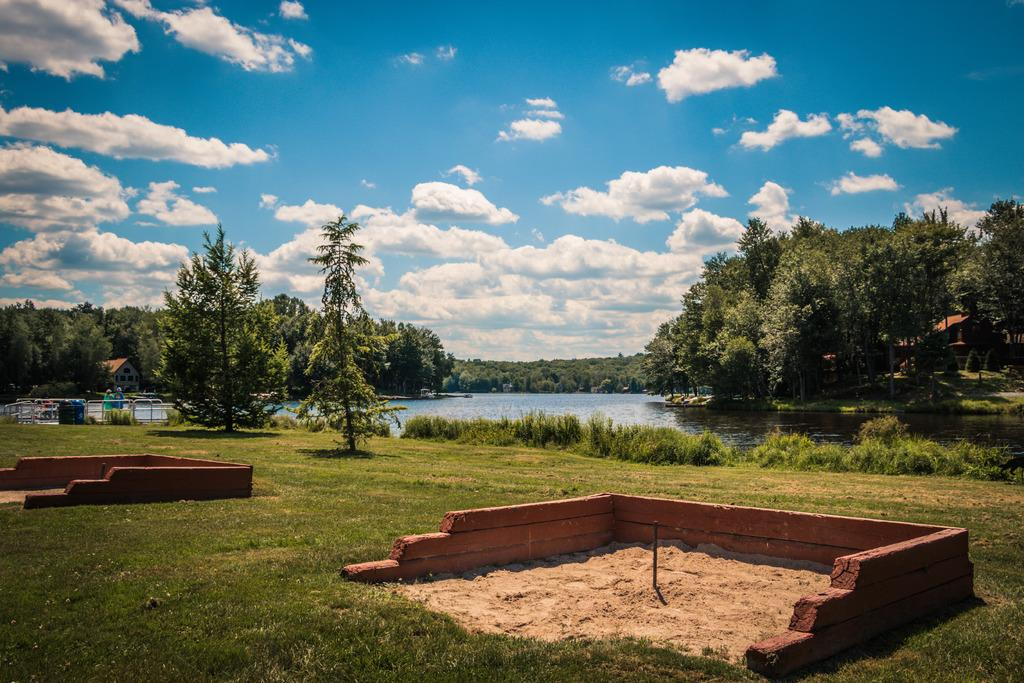What is the main feature in the middle of the picture? There is a lake in the middle of the picture. What type of vegetation is present on the ground? There is grass on the ground. What can be seen in the background of the image? There are trees in the background of the image. What is visible in the sky? There are clouds in the sky. What color is the egg in the box in the image? There is no egg or box present in the image. 